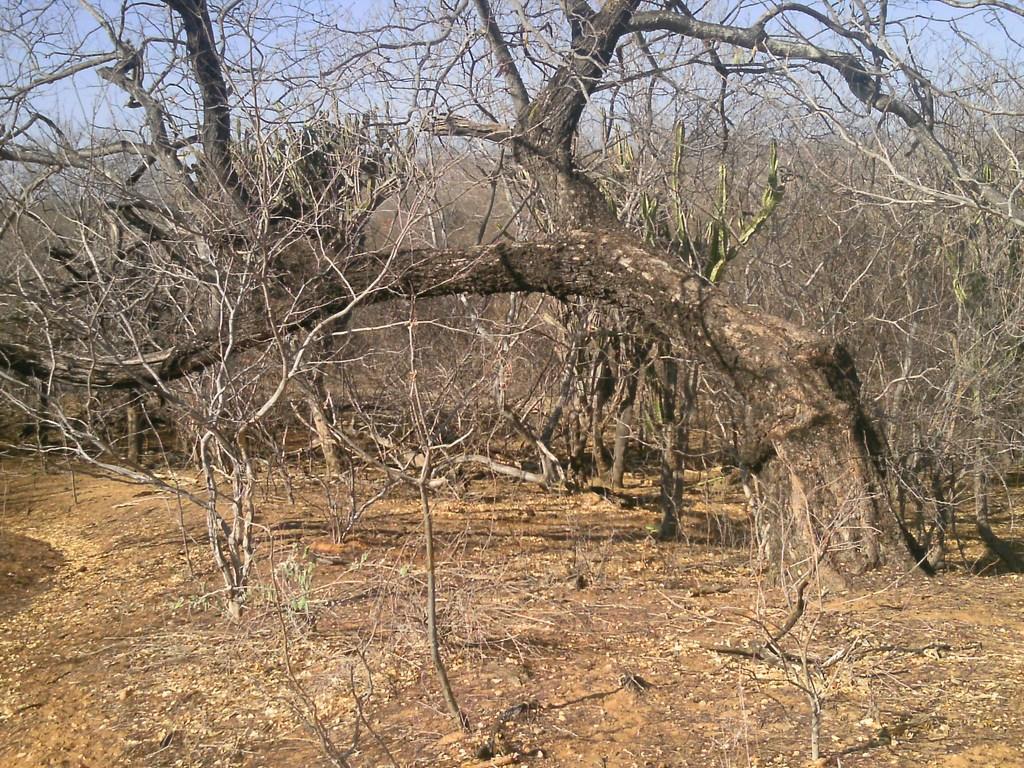Please provide a concise description of this image. In this image trees, ground and sky. 